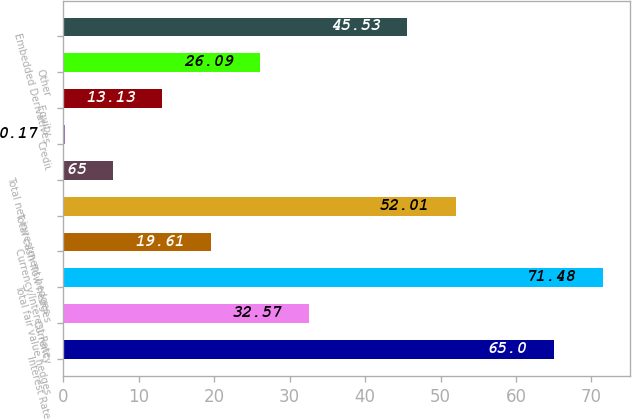Convert chart. <chart><loc_0><loc_0><loc_500><loc_500><bar_chart><fcel>Interest Rate<fcel>Currency<fcel>Total fair value hedges<fcel>Currency/Interest Rate<fcel>Total cash flow hedges<fcel>Total net investment hedges<fcel>Credit<fcel>Equity<fcel>Other<fcel>Embedded Derivatives<nl><fcel>65<fcel>32.57<fcel>71.48<fcel>19.61<fcel>52.01<fcel>6.65<fcel>0.17<fcel>13.13<fcel>26.09<fcel>45.53<nl></chart> 